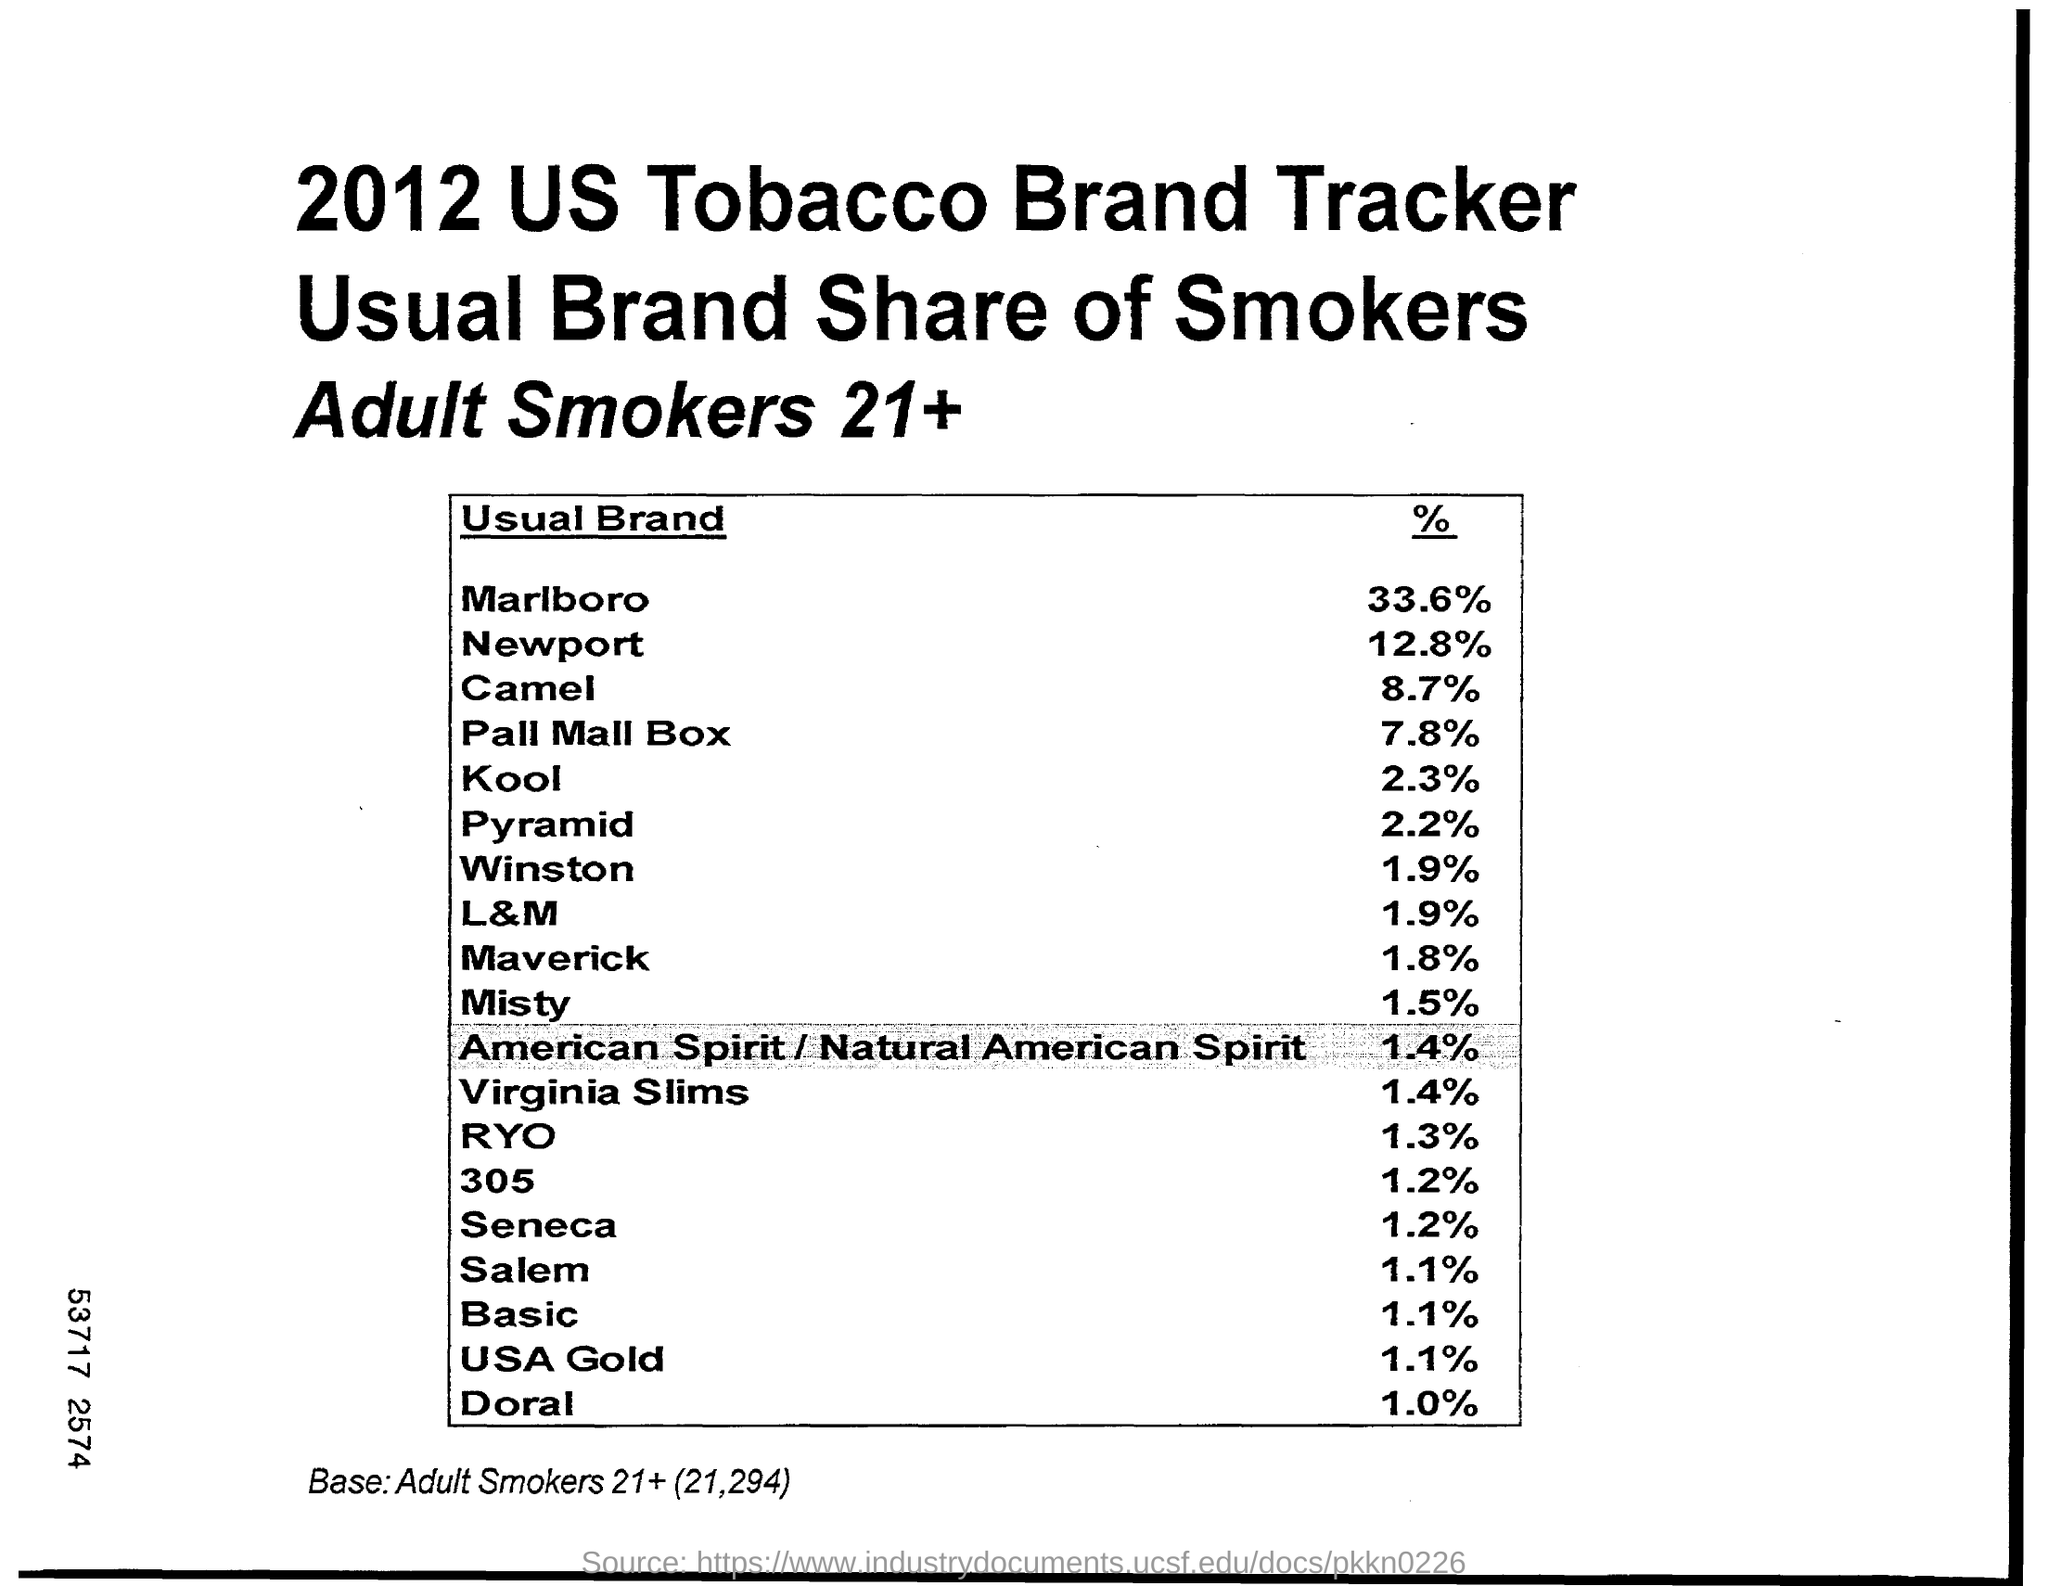Outline some significant characteristics in this image. According to a recent survey, the percentage of consumers who consider the brand "Camel" to be their usual brand of cigarettes is 8.7%. Out of all the usual brands sold in the market, only 1.1% belong to the brand 'Salem'. 